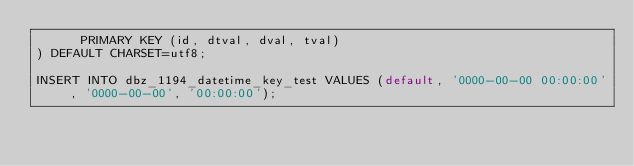Convert code to text. <code><loc_0><loc_0><loc_500><loc_500><_SQL_>      PRIMARY KEY (id, dtval, dval, tval)
) DEFAULT CHARSET=utf8;

INSERT INTO dbz_1194_datetime_key_test VALUES (default, '0000-00-00 00:00:00', '0000-00-00', '00:00:00');
</code> 